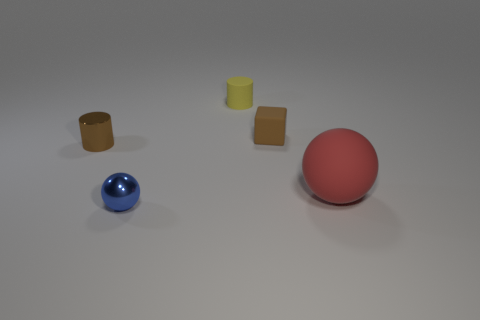Do the tiny metallic cylinder and the matte block have the same color?
Give a very brief answer. Yes. Are there more gray rubber cubes than tiny brown objects?
Ensure brevity in your answer.  No. How many things are both behind the tiny blue shiny object and in front of the red matte sphere?
Make the answer very short. 0. The small object in front of the tiny metallic object that is behind the rubber object in front of the brown cylinder is what shape?
Make the answer very short. Sphere. Are there any other things that have the same shape as the brown rubber object?
Ensure brevity in your answer.  No. How many blocks are blue objects or metallic objects?
Keep it short and to the point. 0. Do the sphere on the right side of the tiny blue ball and the small block have the same color?
Your answer should be very brief. No. What material is the tiny brown thing that is behind the cylinder on the left side of the shiny object that is in front of the large red object?
Offer a very short reply. Rubber. Does the matte ball have the same size as the rubber cube?
Your answer should be very brief. No. There is a big matte object; is its color the same as the small thing in front of the small brown cylinder?
Make the answer very short. No. 